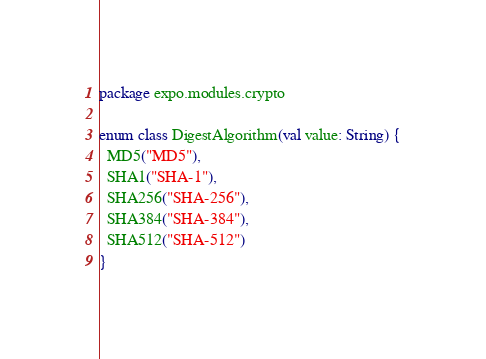Convert code to text. <code><loc_0><loc_0><loc_500><loc_500><_Kotlin_>package expo.modules.crypto

enum class DigestAlgorithm(val value: String) {
  MD5("MD5"),
  SHA1("SHA-1"),
  SHA256("SHA-256"),
  SHA384("SHA-384"),
  SHA512("SHA-512")
}
</code> 